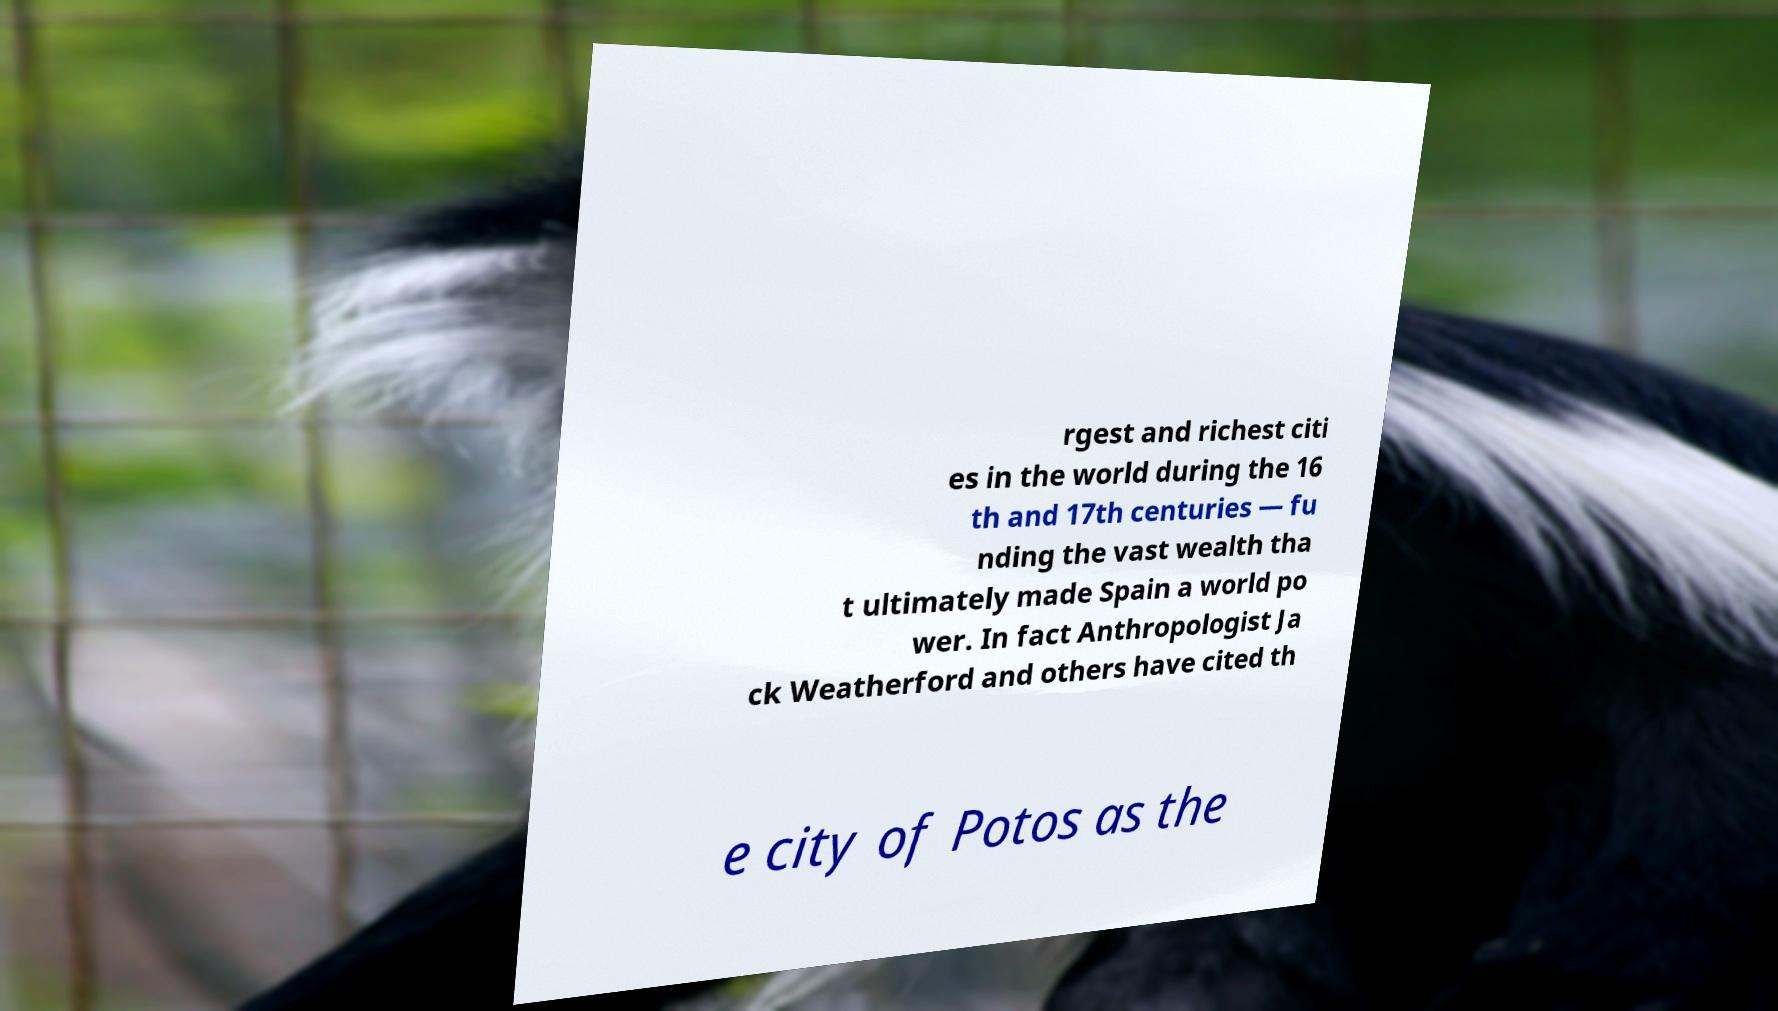Could you assist in decoding the text presented in this image and type it out clearly? rgest and richest citi es in the world during the 16 th and 17th centuries — fu nding the vast wealth tha t ultimately made Spain a world po wer. In fact Anthropologist Ja ck Weatherford and others have cited th e city of Potos as the 